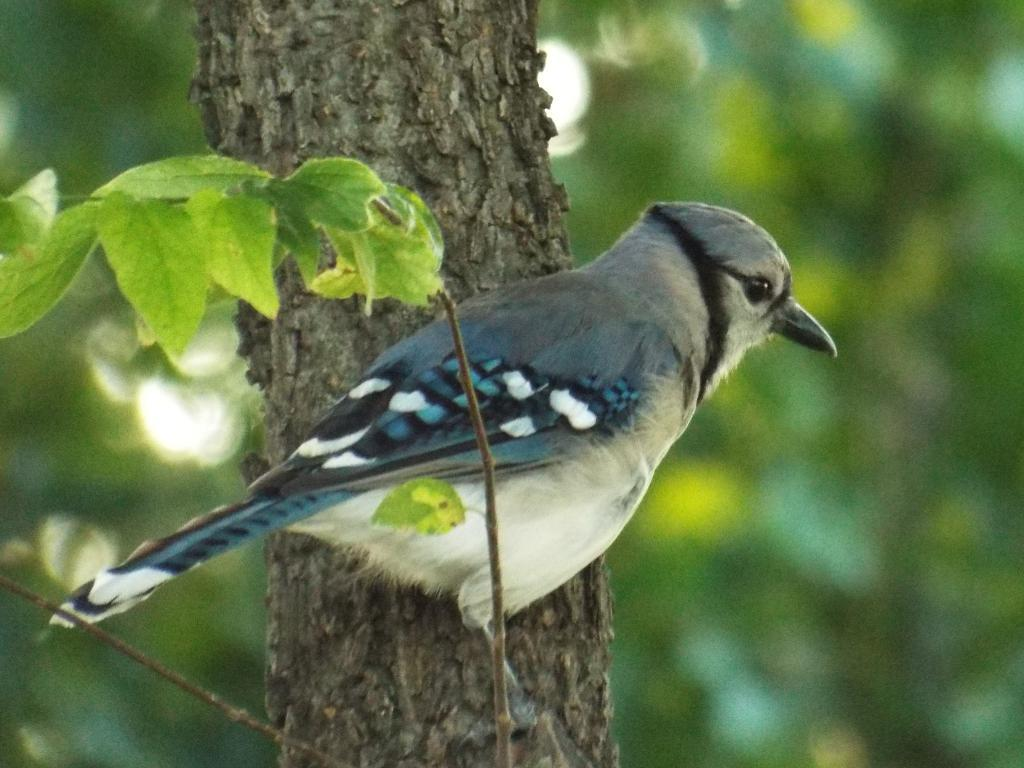What is the main subject of the image? The main subject of the image is a tree trunk. Is there any other living creature visible in the image? Yes, a bird is standing on a small branch beside the tree trunk. How is the background of the image depicted? The background of the tree trunk is blurred. What type of jelly can be seen dripping from the tree trunk in the image? There is no jelly present in the image; it features a tree trunk and a bird. Can you read any letters on the tree trunk in the image? There are no letters visible on the tree trunk in the image. 